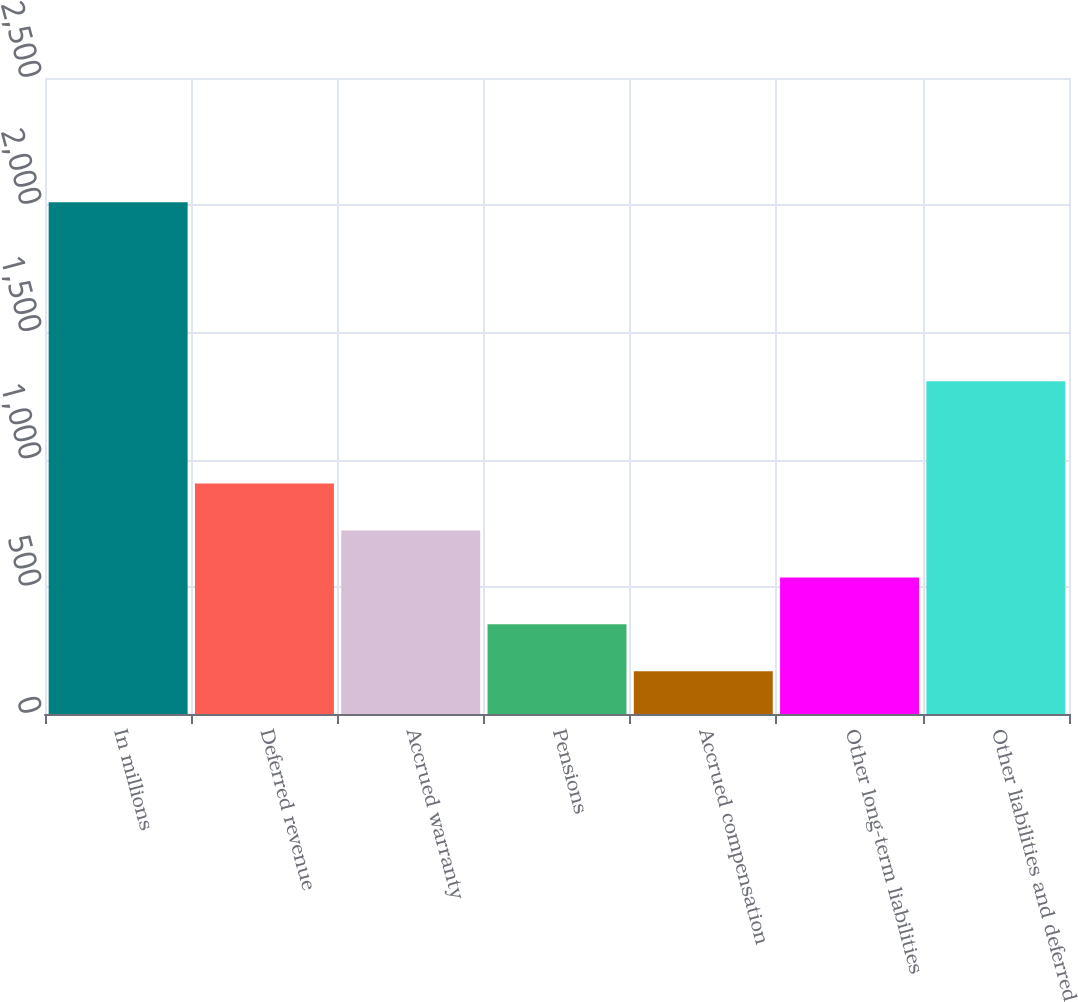<chart> <loc_0><loc_0><loc_500><loc_500><bar_chart><fcel>In millions<fcel>Deferred revenue<fcel>Accrued warranty<fcel>Pensions<fcel>Accrued compensation<fcel>Other long-term liabilities<fcel>Other liabilities and deferred<nl><fcel>2012<fcel>905.6<fcel>721.2<fcel>352.4<fcel>168<fcel>536.8<fcel>1308<nl></chart> 